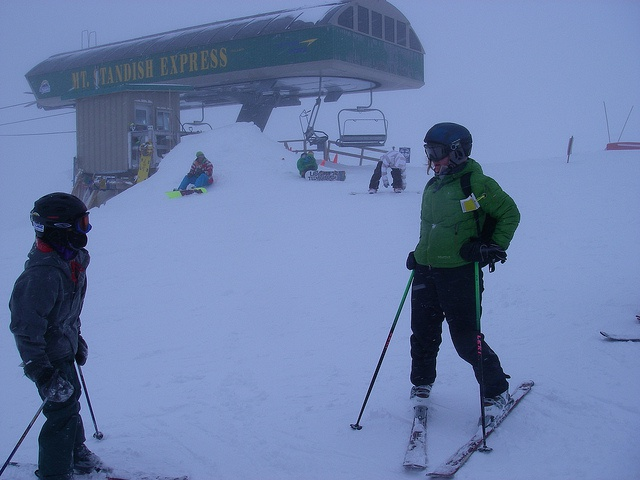Describe the objects in this image and their specific colors. I can see people in gray, black, teal, navy, and darkgreen tones, people in gray, black, navy, darkgray, and darkblue tones, skis in gray, navy, and darkblue tones, people in gray and navy tones, and people in gray, blue, and darkblue tones in this image. 